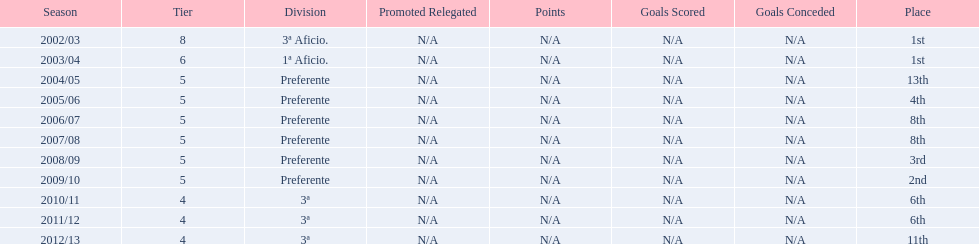What place did the team place in 2010/11? 6th. In what other year did they place 6th? 2011/12. 